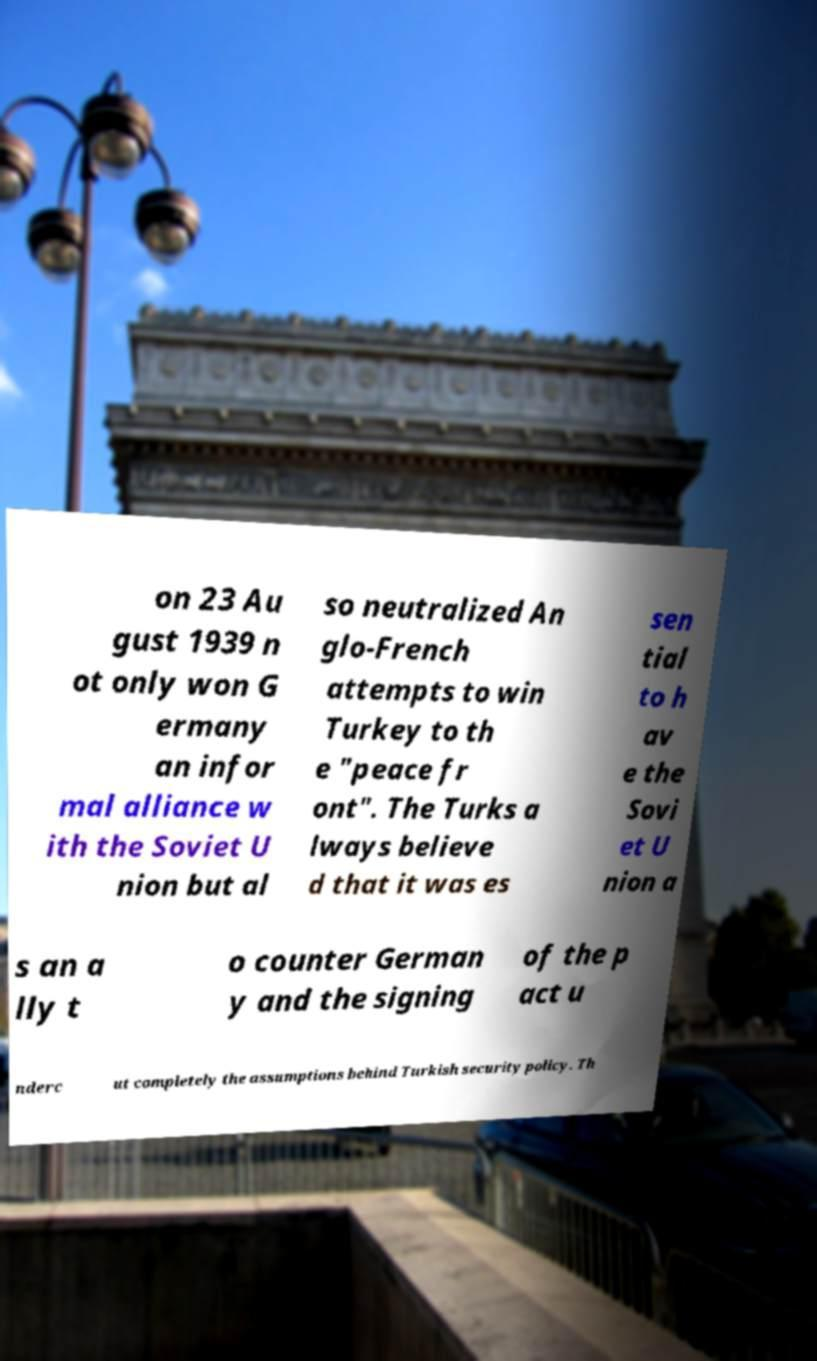I need the written content from this picture converted into text. Can you do that? on 23 Au gust 1939 n ot only won G ermany an infor mal alliance w ith the Soviet U nion but al so neutralized An glo-French attempts to win Turkey to th e "peace fr ont". The Turks a lways believe d that it was es sen tial to h av e the Sovi et U nion a s an a lly t o counter German y and the signing of the p act u nderc ut completely the assumptions behind Turkish security policy. Th 